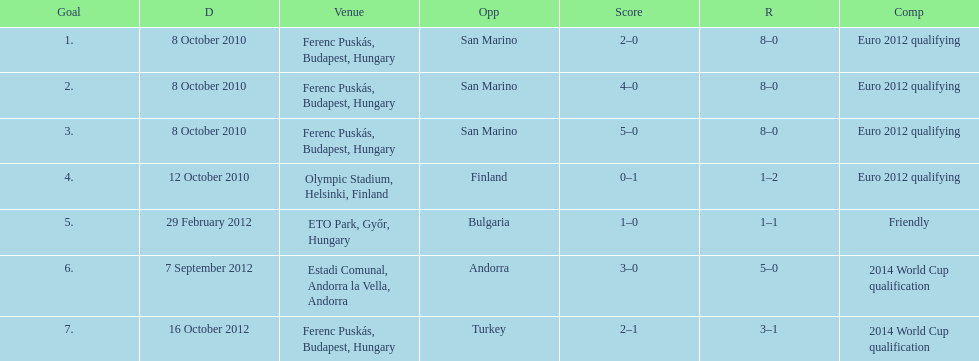Could you parse the entire table? {'header': ['Goal', 'D', 'Venue', 'Opp', 'Score', 'R', 'Comp'], 'rows': [['1.', '8 October 2010', 'Ferenc Puskás, Budapest, Hungary', 'San Marino', '2–0', '8–0', 'Euro 2012 qualifying'], ['2.', '8 October 2010', 'Ferenc Puskás, Budapest, Hungary', 'San Marino', '4–0', '8–0', 'Euro 2012 qualifying'], ['3.', '8 October 2010', 'Ferenc Puskás, Budapest, Hungary', 'San Marino', '5–0', '8–0', 'Euro 2012 qualifying'], ['4.', '12 October 2010', 'Olympic Stadium, Helsinki, Finland', 'Finland', '0–1', '1–2', 'Euro 2012 qualifying'], ['5.', '29 February 2012', 'ETO Park, Győr, Hungary', 'Bulgaria', '1–0', '1–1', 'Friendly'], ['6.', '7 September 2012', 'Estadi Comunal, Andorra la Vella, Andorra', 'Andorra', '3–0', '5–0', '2014 World Cup qualification'], ['7.', '16 October 2012', 'Ferenc Puskás, Budapest, Hungary', 'Turkey', '2–1', '3–1', '2014 World Cup qualification']]} How many goals were scored at the euro 2012 qualifying competition? 12. 